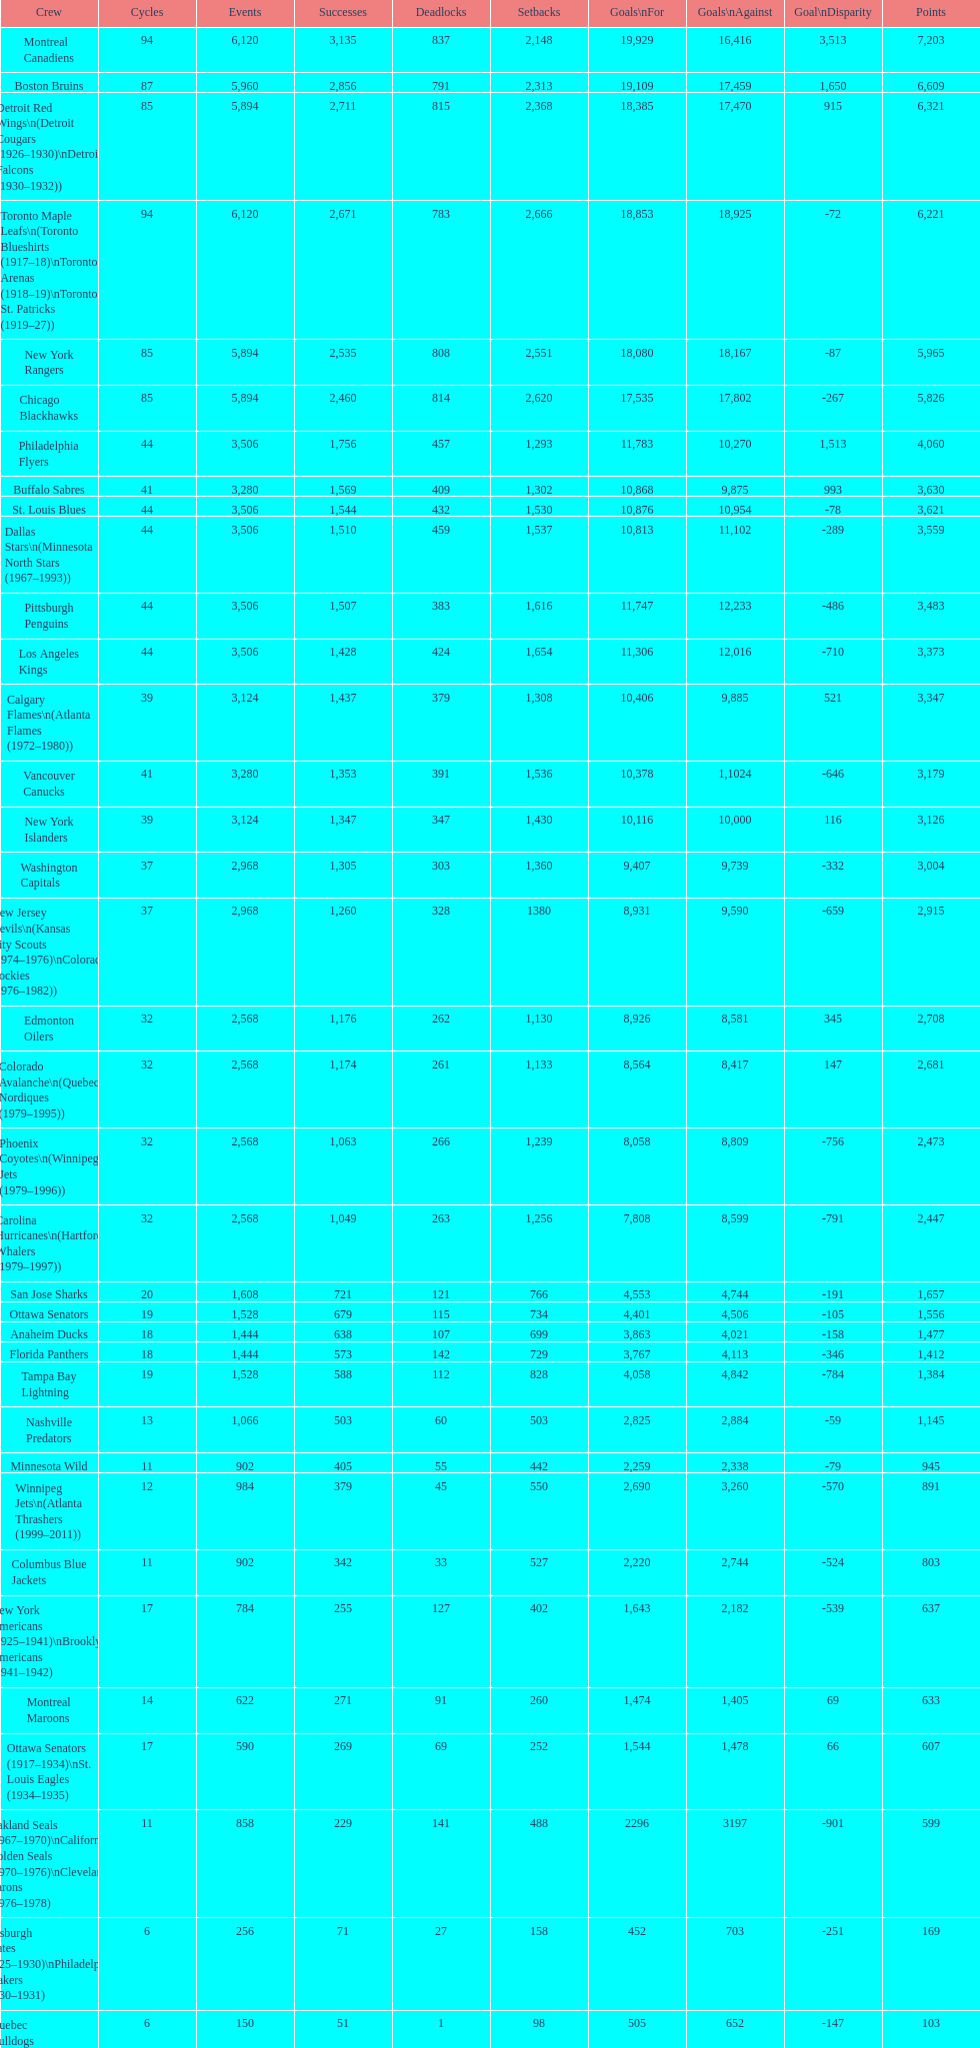How many losses do the st. louis blues have? 1,530. Would you be able to parse every entry in this table? {'header': ['Crew', 'Cycles', 'Events', 'Successes', 'Deadlocks', 'Setbacks', 'Goals\\nFor', 'Goals\\nAgainst', 'Goal\\nDisparity', 'Points'], 'rows': [['Montreal Canadiens', '94', '6,120', '3,135', '837', '2,148', '19,929', '16,416', '3,513', '7,203'], ['Boston Bruins', '87', '5,960', '2,856', '791', '2,313', '19,109', '17,459', '1,650', '6,609'], ['Detroit Red Wings\\n(Detroit Cougars (1926–1930)\\nDetroit Falcons (1930–1932))', '85', '5,894', '2,711', '815', '2,368', '18,385', '17,470', '915', '6,321'], ['Toronto Maple Leafs\\n(Toronto Blueshirts (1917–18)\\nToronto Arenas (1918–19)\\nToronto St. Patricks (1919–27))', '94', '6,120', '2,671', '783', '2,666', '18,853', '18,925', '-72', '6,221'], ['New York Rangers', '85', '5,894', '2,535', '808', '2,551', '18,080', '18,167', '-87', '5,965'], ['Chicago Blackhawks', '85', '5,894', '2,460', '814', '2,620', '17,535', '17,802', '-267', '5,826'], ['Philadelphia Flyers', '44', '3,506', '1,756', '457', '1,293', '11,783', '10,270', '1,513', '4,060'], ['Buffalo Sabres', '41', '3,280', '1,569', '409', '1,302', '10,868', '9,875', '993', '3,630'], ['St. Louis Blues', '44', '3,506', '1,544', '432', '1,530', '10,876', '10,954', '-78', '3,621'], ['Dallas Stars\\n(Minnesota North Stars (1967–1993))', '44', '3,506', '1,510', '459', '1,537', '10,813', '11,102', '-289', '3,559'], ['Pittsburgh Penguins', '44', '3,506', '1,507', '383', '1,616', '11,747', '12,233', '-486', '3,483'], ['Los Angeles Kings', '44', '3,506', '1,428', '424', '1,654', '11,306', '12,016', '-710', '3,373'], ['Calgary Flames\\n(Atlanta Flames (1972–1980))', '39', '3,124', '1,437', '379', '1,308', '10,406', '9,885', '521', '3,347'], ['Vancouver Canucks', '41', '3,280', '1,353', '391', '1,536', '10,378', '1,1024', '-646', '3,179'], ['New York Islanders', '39', '3,124', '1,347', '347', '1,430', '10,116', '10,000', '116', '3,126'], ['Washington Capitals', '37', '2,968', '1,305', '303', '1,360', '9,407', '9,739', '-332', '3,004'], ['New Jersey Devils\\n(Kansas City Scouts (1974–1976)\\nColorado Rockies (1976–1982))', '37', '2,968', '1,260', '328', '1380', '8,931', '9,590', '-659', '2,915'], ['Edmonton Oilers', '32', '2,568', '1,176', '262', '1,130', '8,926', '8,581', '345', '2,708'], ['Colorado Avalanche\\n(Quebec Nordiques (1979–1995))', '32', '2,568', '1,174', '261', '1,133', '8,564', '8,417', '147', '2,681'], ['Phoenix Coyotes\\n(Winnipeg Jets (1979–1996))', '32', '2,568', '1,063', '266', '1,239', '8,058', '8,809', '-756', '2,473'], ['Carolina Hurricanes\\n(Hartford Whalers (1979–1997))', '32', '2,568', '1,049', '263', '1,256', '7,808', '8,599', '-791', '2,447'], ['San Jose Sharks', '20', '1,608', '721', '121', '766', '4,553', '4,744', '-191', '1,657'], ['Ottawa Senators', '19', '1,528', '679', '115', '734', '4,401', '4,506', '-105', '1,556'], ['Anaheim Ducks', '18', '1,444', '638', '107', '699', '3,863', '4,021', '-158', '1,477'], ['Florida Panthers', '18', '1,444', '573', '142', '729', '3,767', '4,113', '-346', '1,412'], ['Tampa Bay Lightning', '19', '1,528', '588', '112', '828', '4,058', '4,842', '-784', '1,384'], ['Nashville Predators', '13', '1,066', '503', '60', '503', '2,825', '2,884', '-59', '1,145'], ['Minnesota Wild', '11', '902', '405', '55', '442', '2,259', '2,338', '-79', '945'], ['Winnipeg Jets\\n(Atlanta Thrashers (1999–2011))', '12', '984', '379', '45', '550', '2,690', '3,260', '-570', '891'], ['Columbus Blue Jackets', '11', '902', '342', '33', '527', '2,220', '2,744', '-524', '803'], ['New York Americans (1925–1941)\\nBrooklyn Americans (1941–1942)', '17', '784', '255', '127', '402', '1,643', '2,182', '-539', '637'], ['Montreal Maroons', '14', '622', '271', '91', '260', '1,474', '1,405', '69', '633'], ['Ottawa Senators (1917–1934)\\nSt. Louis Eagles (1934–1935)', '17', '590', '269', '69', '252', '1,544', '1,478', '66', '607'], ['Oakland Seals (1967–1970)\\nCalifornia Golden Seals (1970–1976)\\nCleveland Barons (1976–1978)', '11', '858', '229', '141', '488', '2296', '3197', '-901', '599'], ['Pittsburgh Pirates (1925–1930)\\nPhiladelphia Quakers (1930–1931)', '6', '256', '71', '27', '158', '452', '703', '-251', '169'], ['Quebec Bulldogs (1919–1920)\\nHamilton Tigers (1920–1925)', '6', '150', '51', '1', '98', '505', '652', '-147', '103'], ['Montreal Wanderers', '1', '6', '1', '0', '5', '17', '35', '-18', '2']]} 